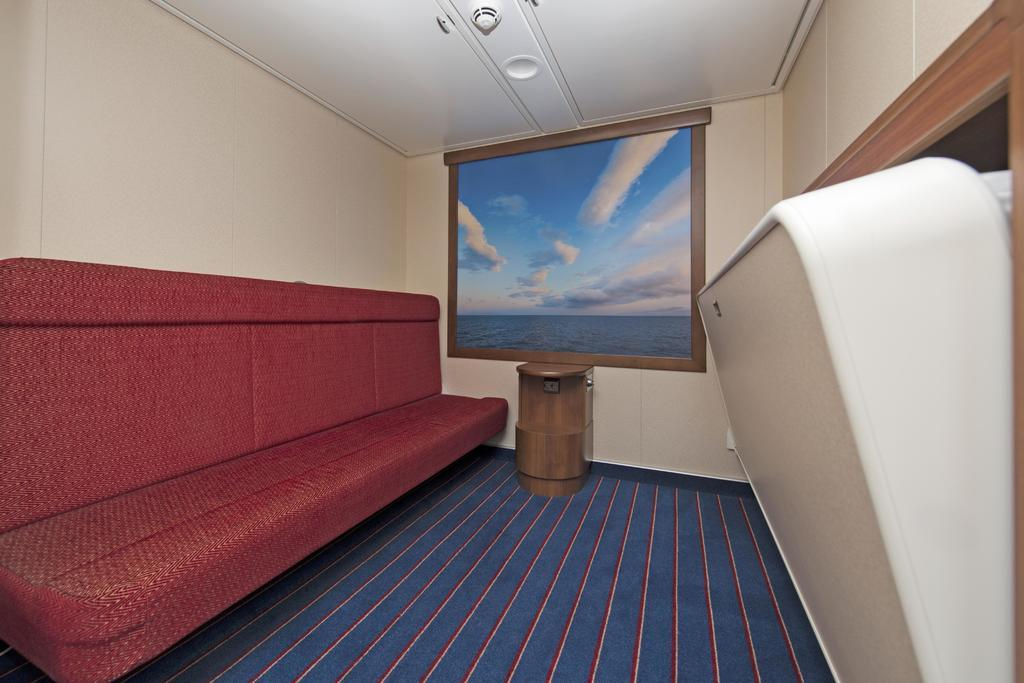What type of furniture is present in the image? There is a sofa and a table in the image. What color is the floor in the image? The floor is blue in the image. What color is the background in the image? The background is white in the image. What type of lead can be seen connecting the sofa and the table in the image? There is no lead connecting the sofa and the table in the image. 